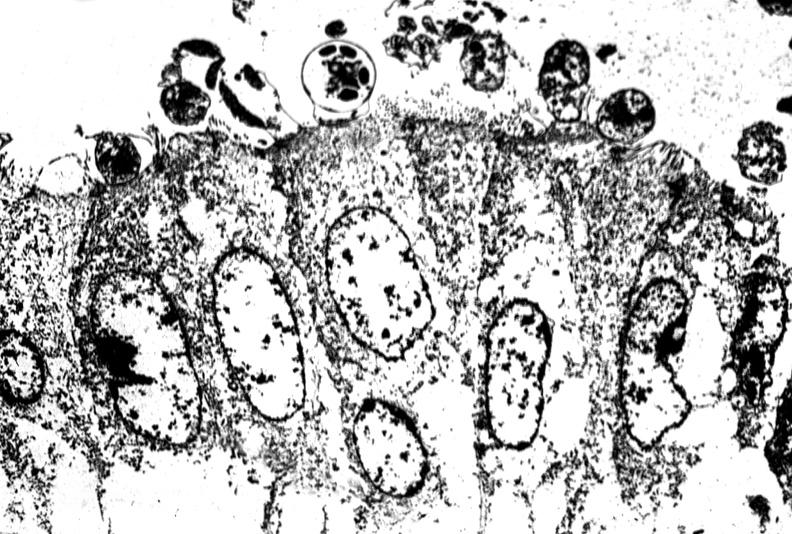does this image show colon biopsy, cryptosporidia?
Answer the question using a single word or phrase. Yes 